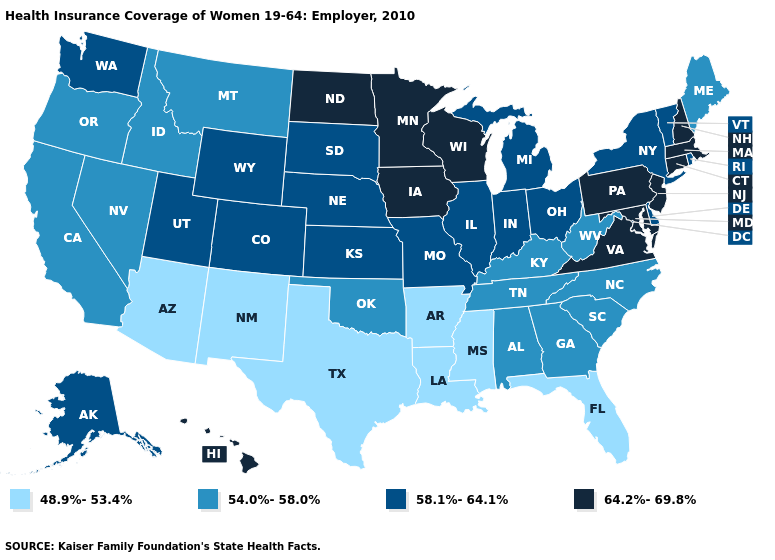Name the states that have a value in the range 64.2%-69.8%?
Give a very brief answer. Connecticut, Hawaii, Iowa, Maryland, Massachusetts, Minnesota, New Hampshire, New Jersey, North Dakota, Pennsylvania, Virginia, Wisconsin. What is the value of Delaware?
Concise answer only. 58.1%-64.1%. Does Massachusetts have the highest value in the USA?
Answer briefly. Yes. How many symbols are there in the legend?
Short answer required. 4. Name the states that have a value in the range 54.0%-58.0%?
Give a very brief answer. Alabama, California, Georgia, Idaho, Kentucky, Maine, Montana, Nevada, North Carolina, Oklahoma, Oregon, South Carolina, Tennessee, West Virginia. Name the states that have a value in the range 48.9%-53.4%?
Quick response, please. Arizona, Arkansas, Florida, Louisiana, Mississippi, New Mexico, Texas. Name the states that have a value in the range 64.2%-69.8%?
Concise answer only. Connecticut, Hawaii, Iowa, Maryland, Massachusetts, Minnesota, New Hampshire, New Jersey, North Dakota, Pennsylvania, Virginia, Wisconsin. What is the value of North Carolina?
Keep it brief. 54.0%-58.0%. Does the first symbol in the legend represent the smallest category?
Quick response, please. Yes. Does Mississippi have the lowest value in the USA?
Be succinct. Yes. Which states hav the highest value in the MidWest?
Be succinct. Iowa, Minnesota, North Dakota, Wisconsin. Among the states that border Oregon , does Nevada have the lowest value?
Answer briefly. Yes. What is the value of Hawaii?
Keep it brief. 64.2%-69.8%. What is the value of Indiana?
Be succinct. 58.1%-64.1%. 